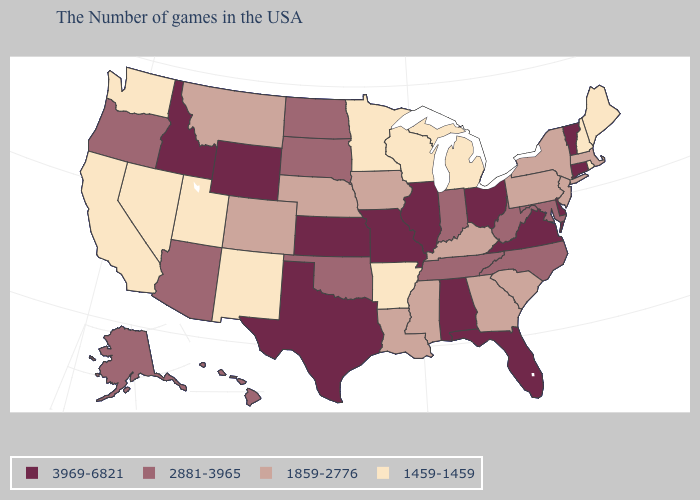Is the legend a continuous bar?
Give a very brief answer. No. What is the value of Arkansas?
Be succinct. 1459-1459. Among the states that border Nebraska , which have the highest value?
Be succinct. Missouri, Kansas, Wyoming. How many symbols are there in the legend?
Give a very brief answer. 4. Does Kentucky have a higher value than California?
Give a very brief answer. Yes. Among the states that border Georgia , does Alabama have the highest value?
Keep it brief. Yes. Name the states that have a value in the range 1859-2776?
Give a very brief answer. Massachusetts, New York, New Jersey, Pennsylvania, South Carolina, Georgia, Kentucky, Mississippi, Louisiana, Iowa, Nebraska, Colorado, Montana. What is the value of Alabama?
Short answer required. 3969-6821. What is the highest value in states that border Georgia?
Keep it brief. 3969-6821. What is the lowest value in states that border Arkansas?
Be succinct. 1859-2776. What is the value of North Dakota?
Answer briefly. 2881-3965. Is the legend a continuous bar?
Short answer required. No. What is the value of Vermont?
Concise answer only. 3969-6821. What is the value of Alabama?
Short answer required. 3969-6821. 